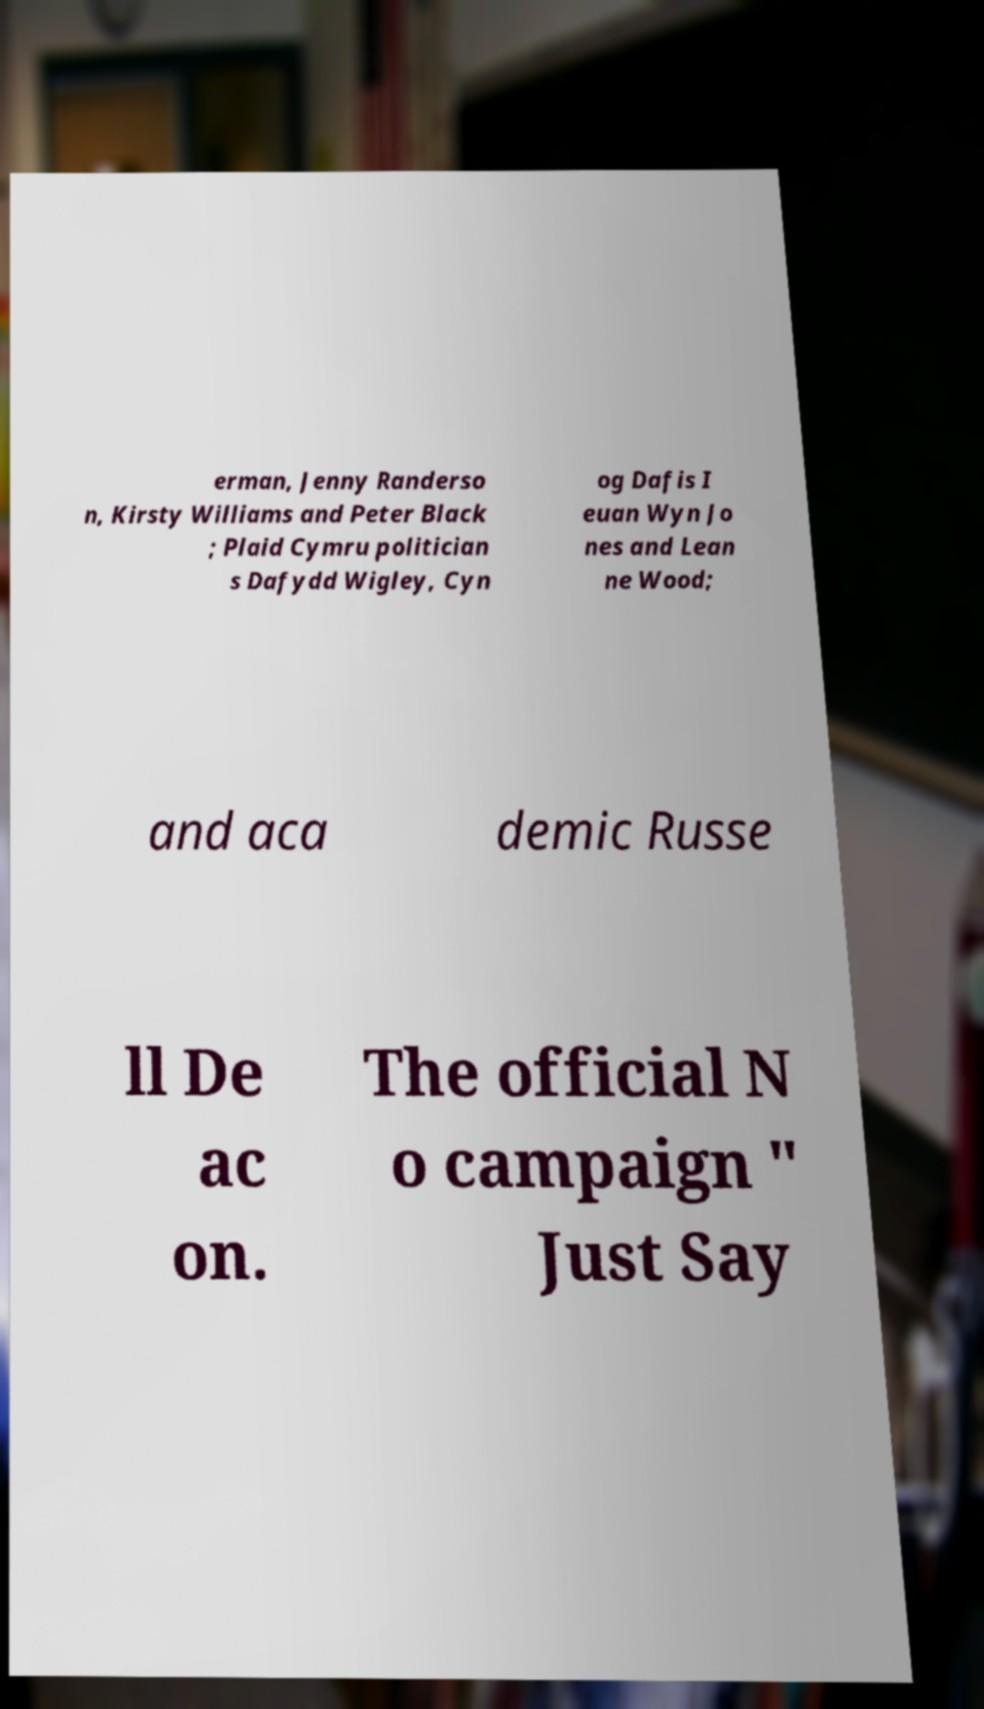For documentation purposes, I need the text within this image transcribed. Could you provide that? erman, Jenny Randerso n, Kirsty Williams and Peter Black ; Plaid Cymru politician s Dafydd Wigley, Cyn og Dafis I euan Wyn Jo nes and Lean ne Wood; and aca demic Russe ll De ac on. The official N o campaign " Just Say 